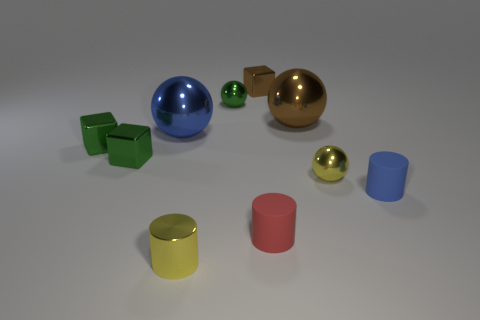What could be the purpose of arranging these objects? The arrangement of these objects seems to be a display, potentially for showcasing the effects of different colors and materials under similar lighting conditions. It's reminiscent of a 3D rendering test scene where artists check how light interacts with surfaces. 